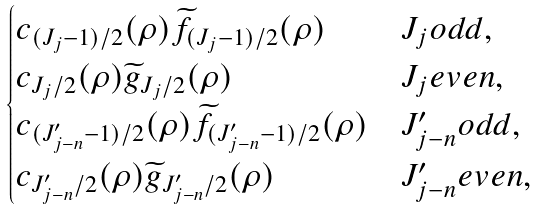Convert formula to latex. <formula><loc_0><loc_0><loc_500><loc_500>\begin{cases} c _ { ( J _ { j } - 1 ) / 2 } ( \rho ) \widetilde { f } _ { ( J _ { j } - 1 ) / 2 } ( \rho ) & J _ { j } o d d , \\ c _ { J _ { j } / 2 } ( \rho ) \widetilde { g } _ { J _ { j } / 2 } ( \rho ) & J _ { j } e v e n , \\ c _ { ( J ^ { \prime } _ { j - n } - 1 ) / 2 } ( \rho ) \widetilde { f } _ { ( J ^ { \prime } _ { j - n } - 1 ) / 2 } ( \rho ) & J ^ { \prime } _ { j - n } o d d , \\ c _ { J ^ { \prime } _ { j - n } / 2 } ( \rho ) \widetilde { g } _ { J ^ { \prime } _ { j - n } / 2 } ( \rho ) & J ^ { \prime } _ { j - n } e v e n , \end{cases}</formula> 